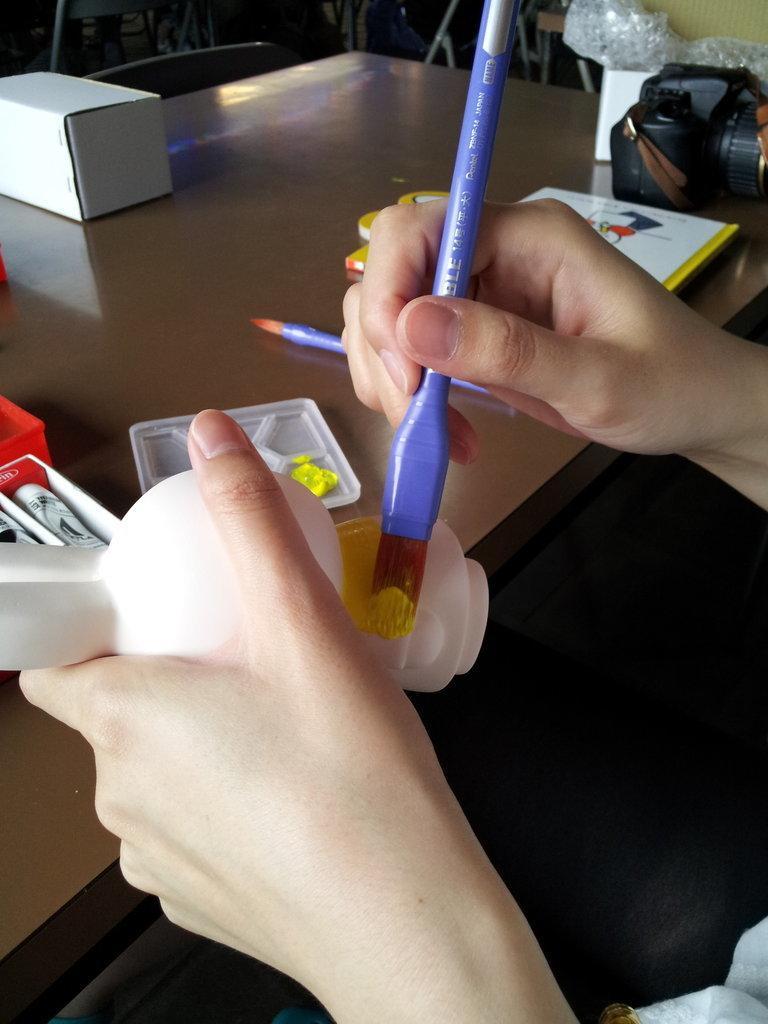Could you give a brief overview of what you see in this image? In this picture I can see there is a person holding a white color object and painting brush and is painting the object. There is a table in front of the person, there is another paint brush, camera, plate and there are little boxes, books and colors placed on the table. 